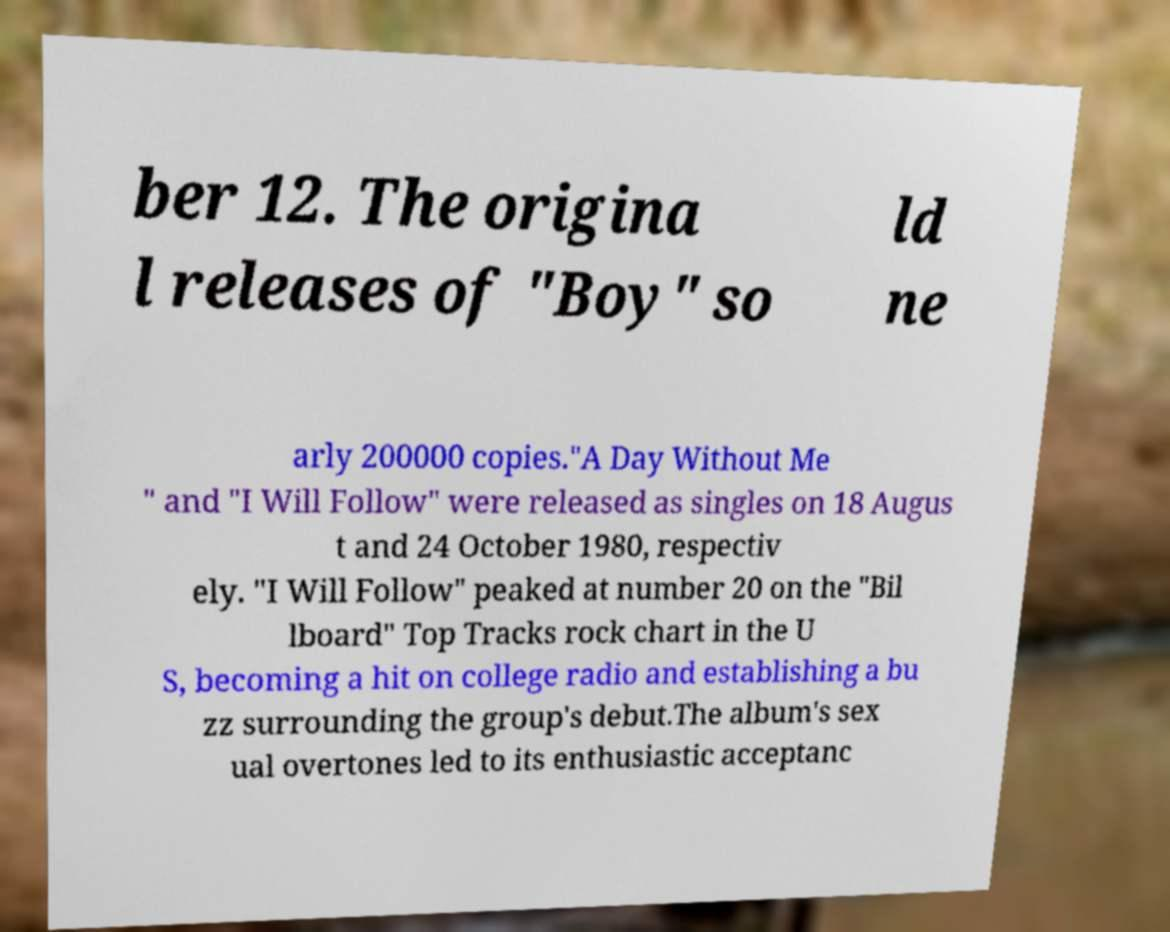Can you read and provide the text displayed in the image?This photo seems to have some interesting text. Can you extract and type it out for me? ber 12. The origina l releases of "Boy" so ld ne arly 200000 copies."A Day Without Me " and "I Will Follow" were released as singles on 18 Augus t and 24 October 1980, respectiv ely. "I Will Follow" peaked at number 20 on the "Bil lboard" Top Tracks rock chart in the U S, becoming a hit on college radio and establishing a bu zz surrounding the group's debut.The album's sex ual overtones led to its enthusiastic acceptanc 